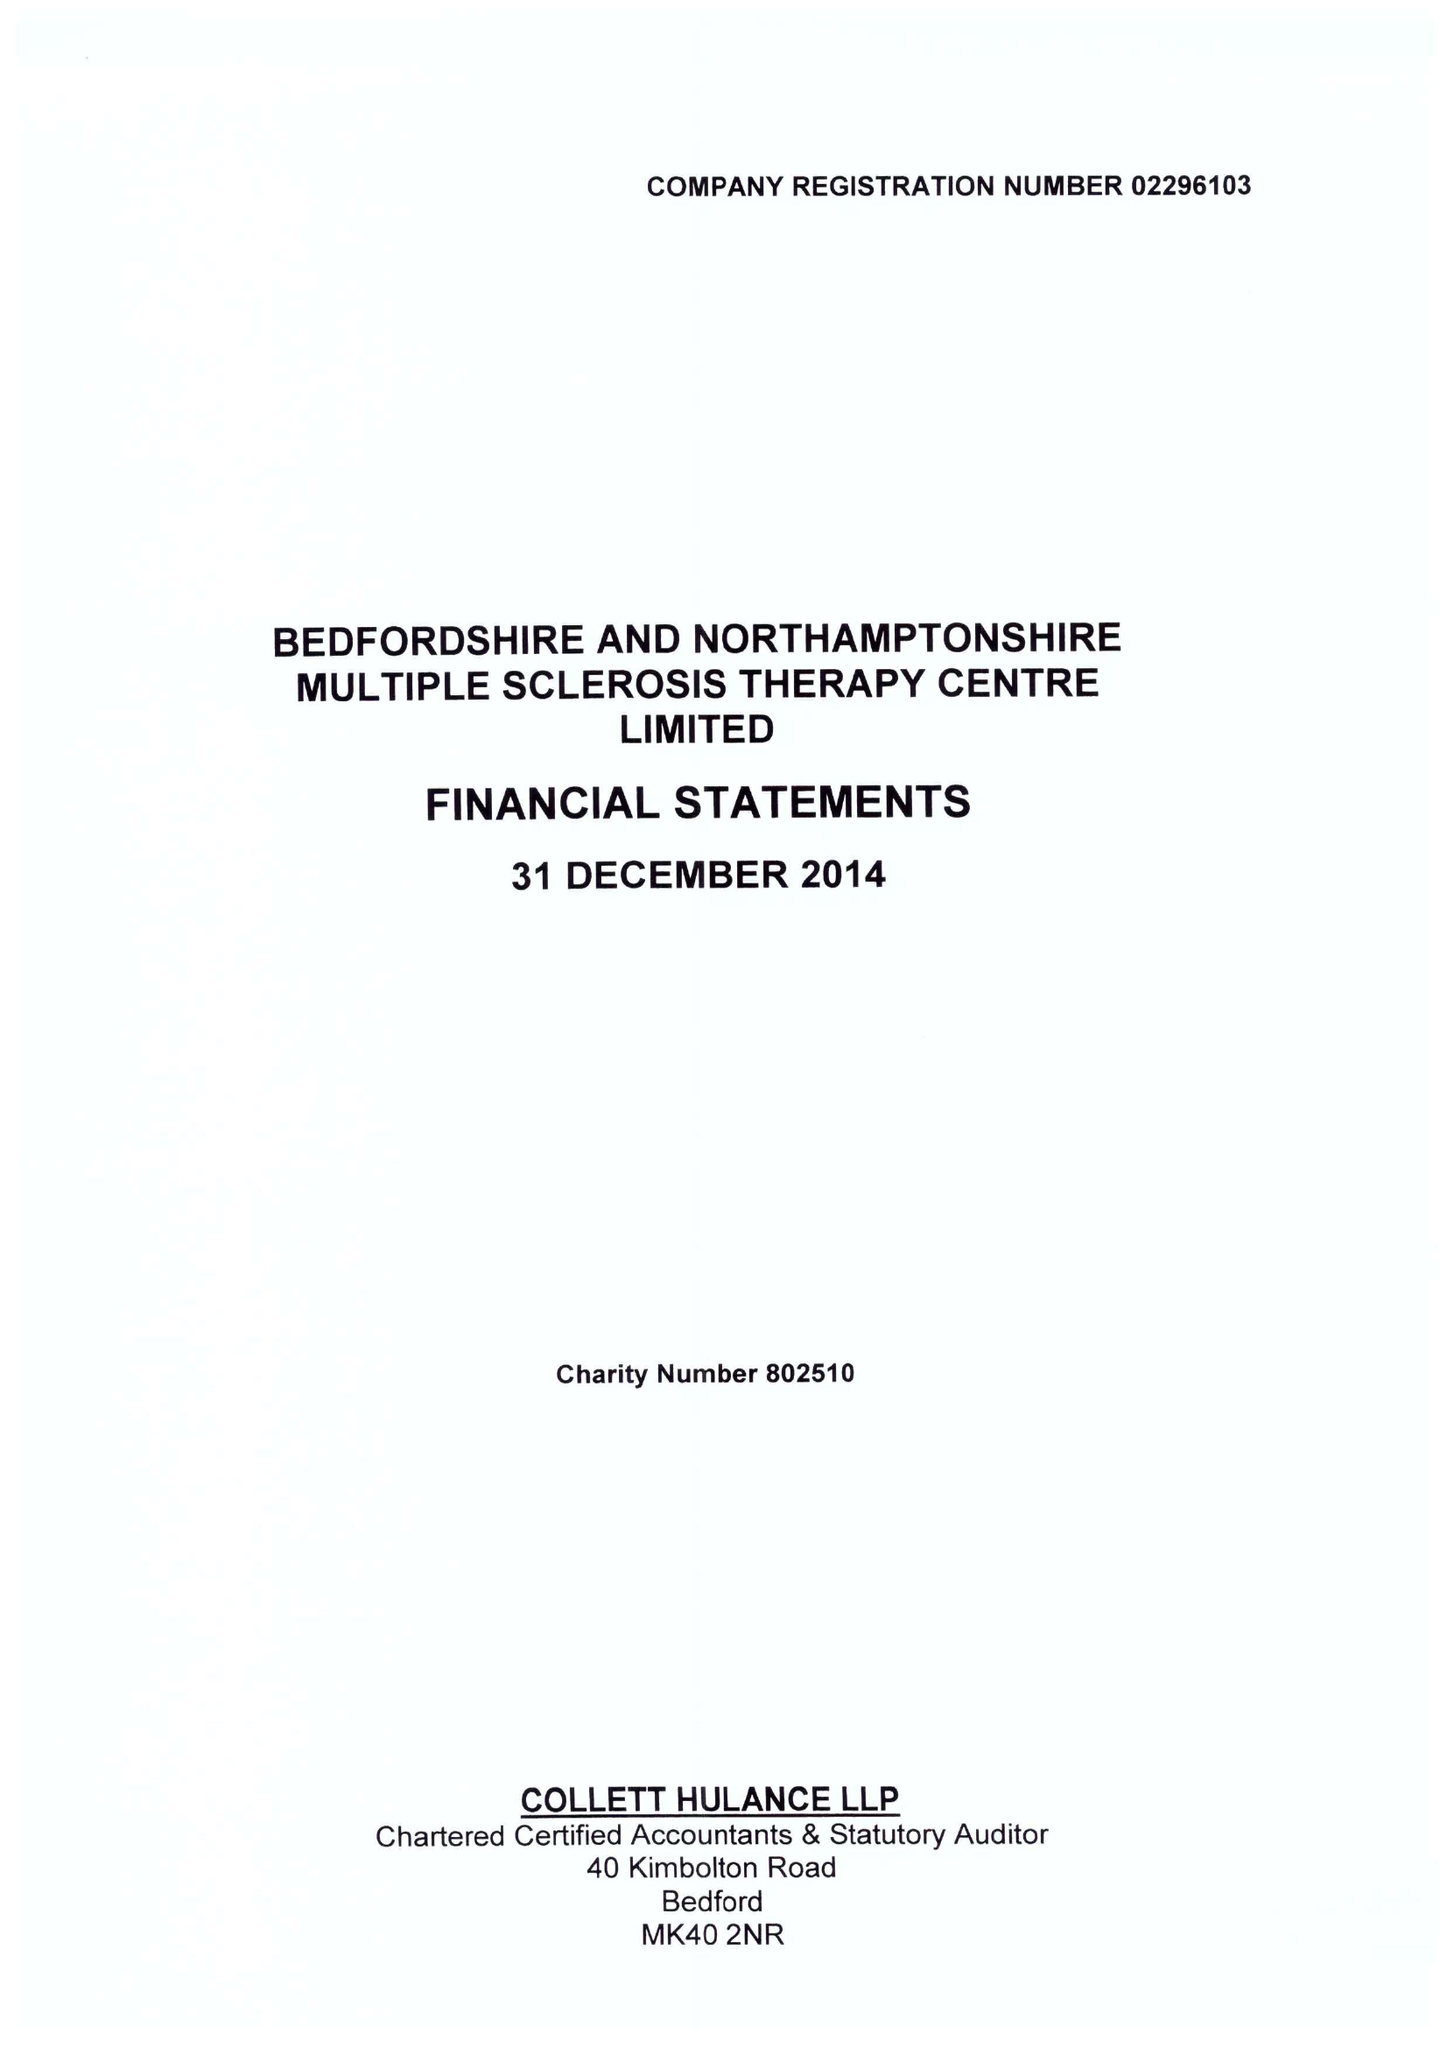What is the value for the charity_name?
Answer the question using a single word or phrase. Bedfordshire and Northamptonshire Multiple Sclerosis Therapy Centre Ltd. 